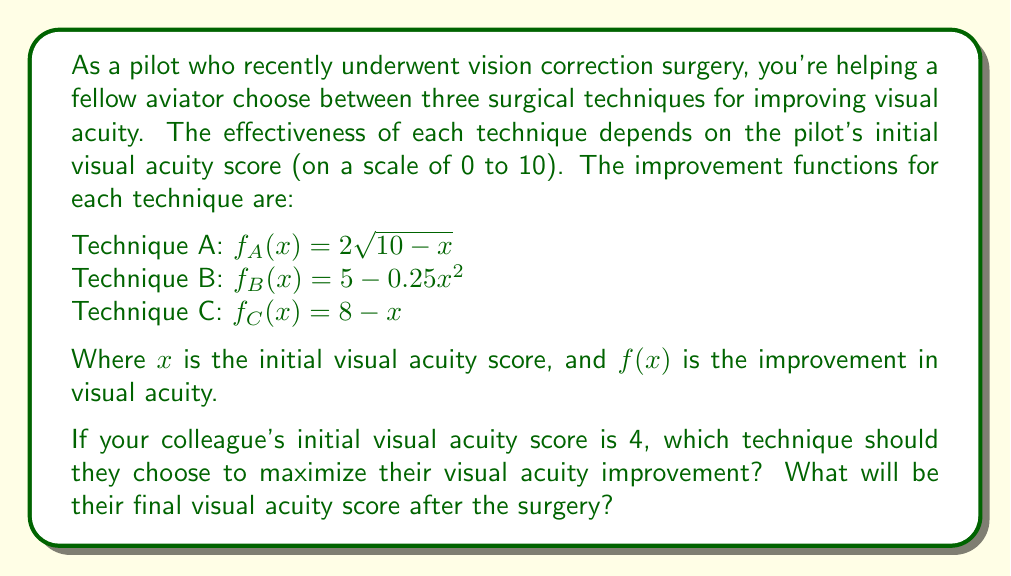Provide a solution to this math problem. To solve this problem, we need to:
1. Calculate the improvement for each technique given the initial visual acuity score of 4.
2. Compare the improvements to find the maximum.
3. Add the maximum improvement to the initial score to get the final visual acuity score.

Let's calculate the improvement for each technique:

1. Technique A: 
   $f_A(4) = 2\sqrt{10-4} = 2\sqrt{6} \approx 4.90$

2. Technique B:
   $f_B(4) = 5 - 0.25(4)^2 = 5 - 0.25(16) = 5 - 4 = 1$

3. Technique C:
   $f_C(4) = 8 - 4 = 4$

Comparing the improvements:
$f_A(4) \approx 4.90$
$f_B(4) = 1$
$f_C(4) = 4$

The maximum improvement is achieved with Technique A, approximately 4.90.

To calculate the final visual acuity score, we add this improvement to the initial score:

Final score = Initial score + Maximum improvement
             = 4 + 4.90 = 8.90

Therefore, your colleague should choose Technique A, and their final visual acuity score will be approximately 8.90.
Answer: Technique A; Final visual acuity score ≈ 8.90 